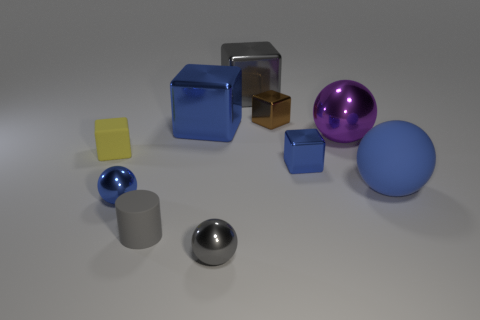There is a small blue shiny object that is on the left side of the metallic block that is in front of the shiny sphere that is behind the large rubber thing; what is its shape?
Your answer should be very brief. Sphere. What number of shiny things are on the left side of the small block to the right of the tiny brown metallic object?
Offer a very short reply. 5. Are the yellow thing and the big purple object made of the same material?
Make the answer very short. No. There is a small brown cube that is right of the small metal sphere that is behind the tiny gray sphere; how many blue spheres are on the left side of it?
Your response must be concise. 1. What is the color of the metal sphere behind the yellow block?
Your response must be concise. Purple. There is a matte thing that is in front of the small blue thing that is left of the tiny gray metallic object; what is its shape?
Provide a short and direct response. Cylinder. How many cubes are either large blue metal objects or large gray objects?
Offer a very short reply. 2. What is the small thing that is both behind the blue rubber object and to the left of the big gray metallic thing made of?
Your response must be concise. Rubber. What number of cubes are behind the tiny yellow thing?
Your answer should be compact. 3. Are the blue sphere to the left of the gray cylinder and the yellow block left of the big purple sphere made of the same material?
Keep it short and to the point. No. 